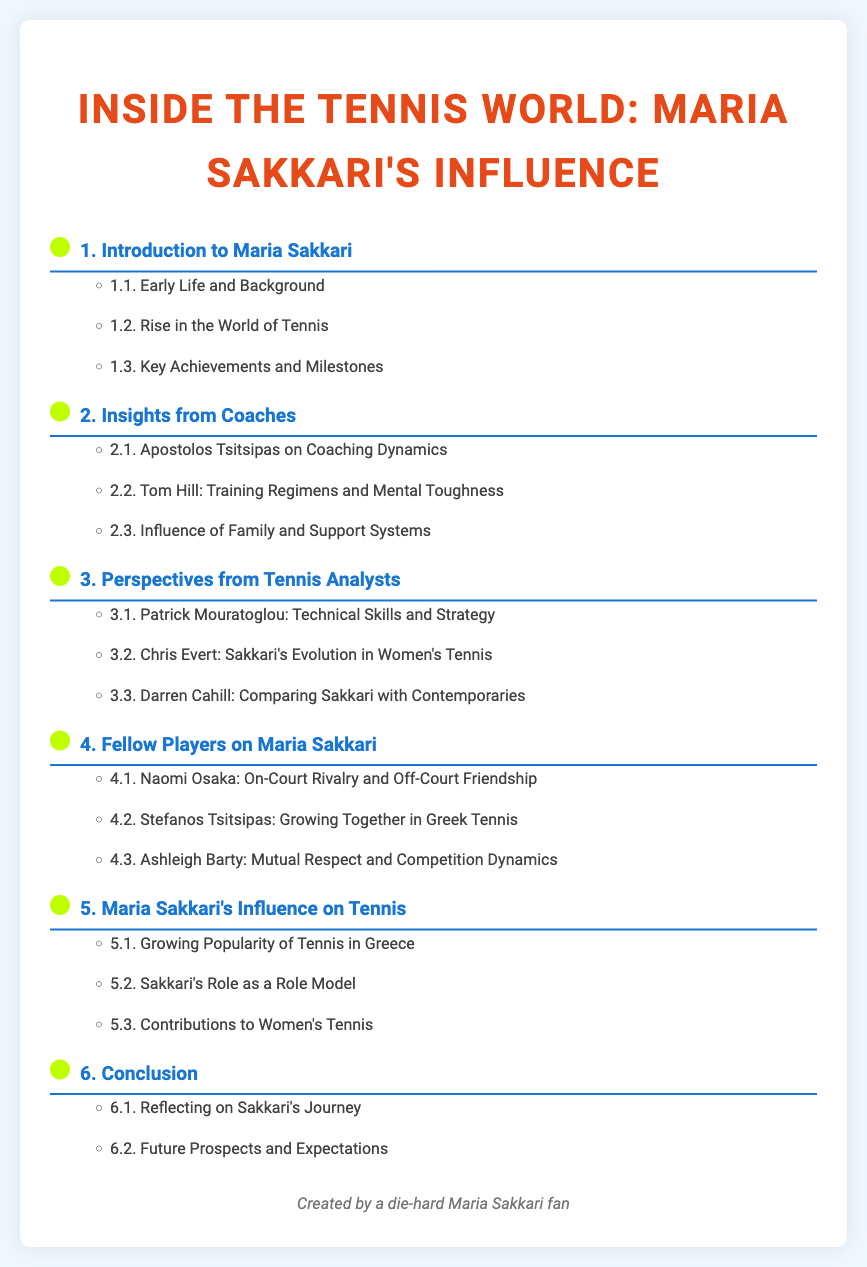What is Maria Sakkari's profession? The document is focused on Maria Sakkari and her influence in the tennis world, which indicates that her profession is tennis player.
Answer: tennis player Who wrote the section on "Influence of Family and Support Systems"? The document lists various sections and their contributors; this section is written by Tom Hill.
Answer: Tom Hill What is the main theme of the document? The document centers around Maria Sakkari and includes interviews and insights related to her impact in tennis, indicating the main theme is her influence.
Answer: influence How many sections are dedicated to insights from coaches? The document outlines different sections; there are three subsections dedicated to insights from coaches.
Answer: 3 Who is mentioned as a fellow player contributing insight? The document lists several fellow players who share their perspectives; Naomi Osaka is one of them.
Answer: Naomi Osaka What is the subtitle of the first section? The first section has several subsections, with "Early Life and Background" being one of them, thus a subtitle signifies its content.
Answer: Early Life and Background In what year was the section "Sakkari's Role as a Role Model" created? The document does not provide a specific year for the section, which is common for a Table of contents, thus there is no date mentioned.
Answer: N/A Which famous coach provided insights on Sakkari's technical skills? The document indicates that Patrick Mouratoglou is the famous coach who provided insights into her technical skills and strategies.
Answer: Patrick Mouratoglou What does section 5 focus on? The fifth section discusses the broader implications of Maria Sakkari's influence on tennis.
Answer: Maria Sakkari's Influence on Tennis 